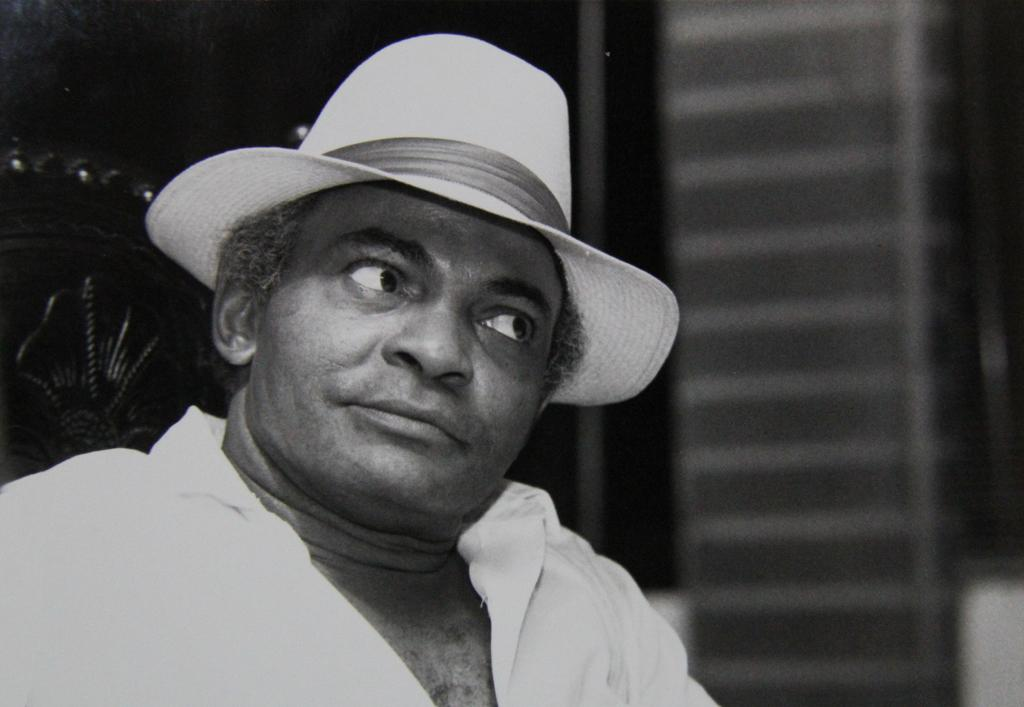What is the main subject of the image? The main subject of the image is a man. Can you describe what the man is wearing on his head? The man is wearing a hat. What is the color of the background in the image? The background of the image is dark. What type of polish is the man applying to his nails in the image? There is no indication in the image that the man is applying any polish to his nails. Is the man depicted as a slave in the image? There is no indication in the image that the man is depicted as a slave. What type of pickle is the man holding in the image? There is no pickle present in the image. 